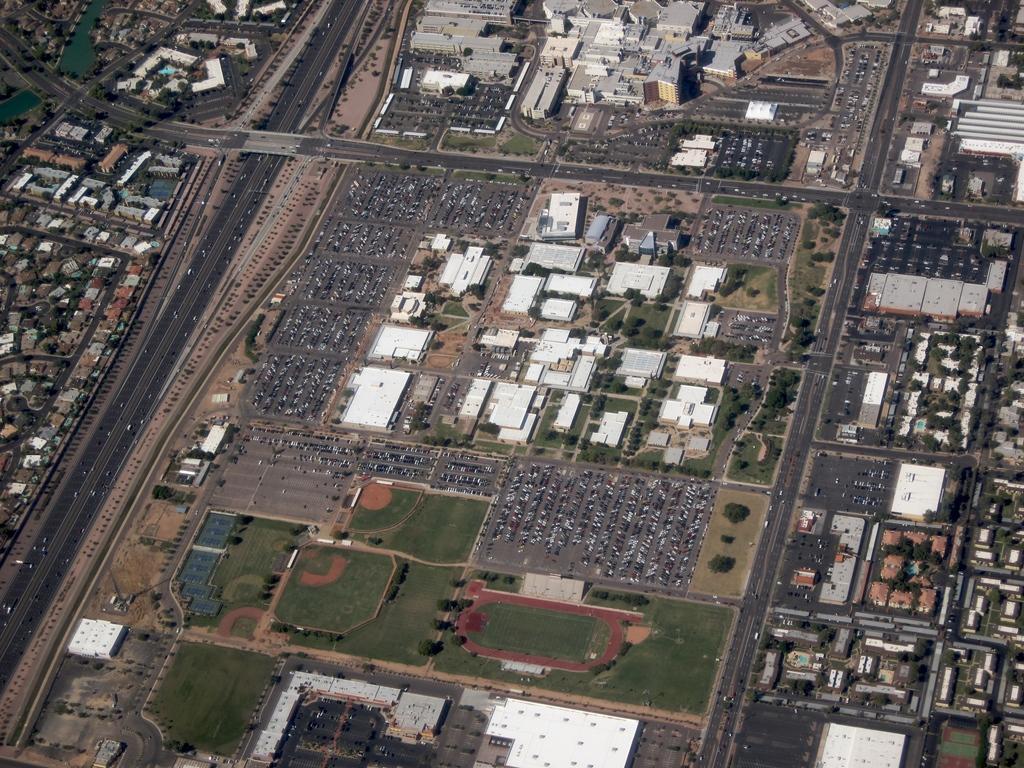How would you summarize this image in a sentence or two? In this image we can see buildings, roads, trees, grass, and objects. 